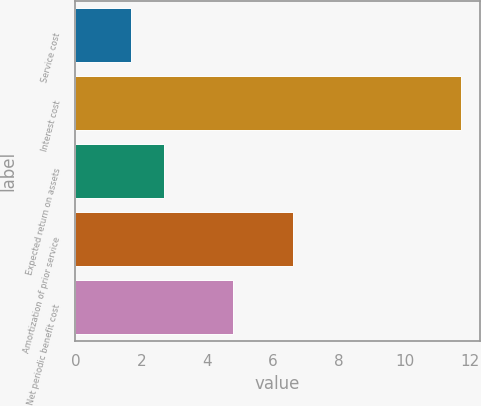Convert chart. <chart><loc_0><loc_0><loc_500><loc_500><bar_chart><fcel>Service cost<fcel>Interest cost<fcel>Expected return on assets<fcel>Amortization of prior service<fcel>Net periodic benefit cost<nl><fcel>1.7<fcel>11.7<fcel>2.7<fcel>6.6<fcel>4.8<nl></chart> 